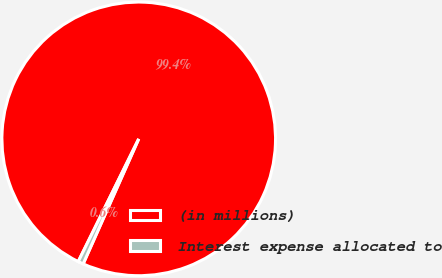Convert chart to OTSL. <chart><loc_0><loc_0><loc_500><loc_500><pie_chart><fcel>(in millions)<fcel>Interest expense allocated to<nl><fcel>99.37%<fcel>0.63%<nl></chart> 